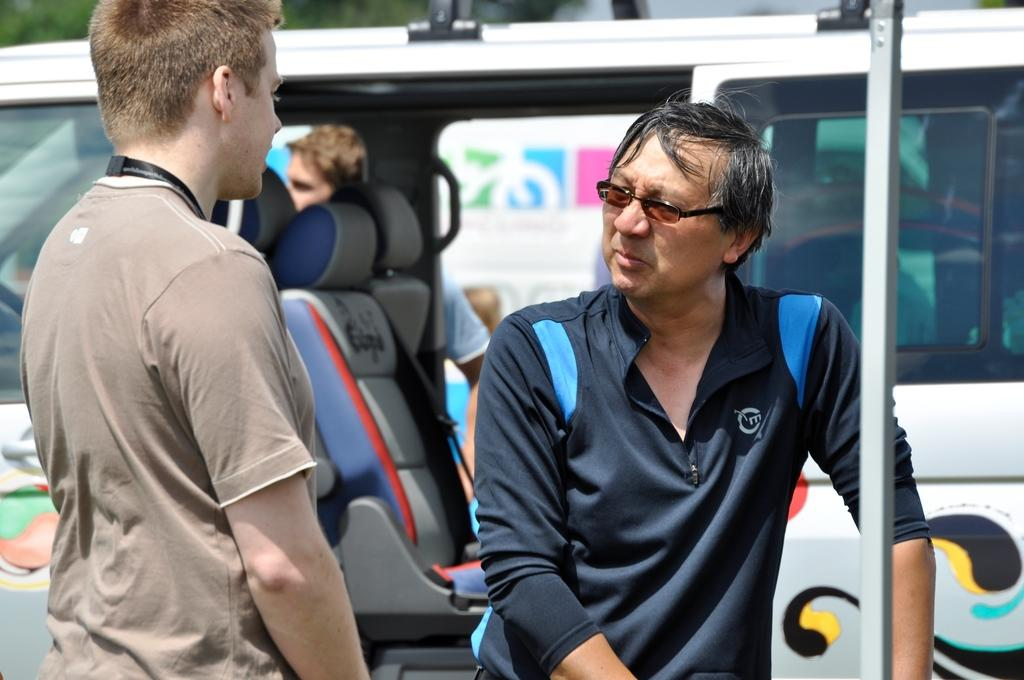How many people are in the image? There are two persons standing in the image. Where are the persons located in the image? The persons are at the bottom of the image. What can be seen in the background of the image? There is a vehicle in the background of the image. What type of mask is the person on the left wearing in the image? There is no mask visible on either person in the image. What route are the persons taking in the wilderness? The image does not depict a wilderness setting, and there is no indication of a route being taken. 